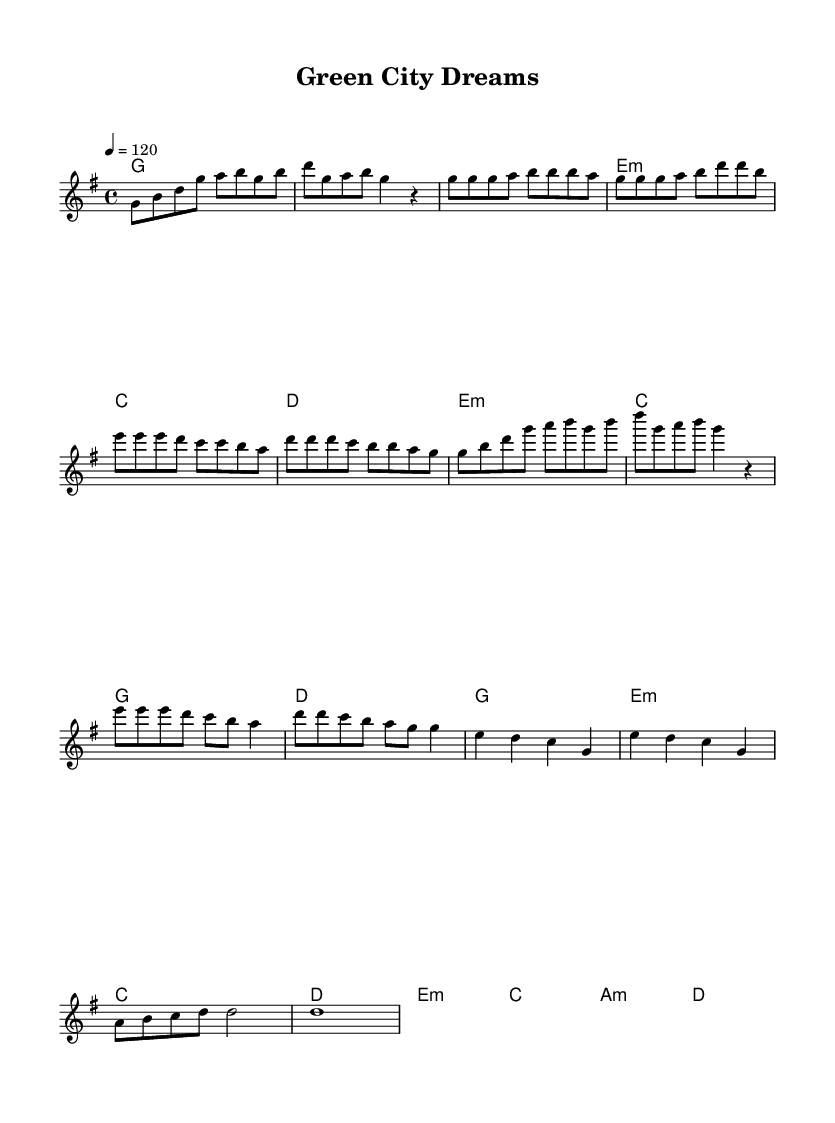What is the key signature of this music? The key signature is G major, which has one sharp (F#). This can be found at the beginning of the score, indicated by the sharp symbol placed on the staff.
Answer: G major What is the time signature of this composition? The time signature is four-four, which is indicated by the "4/4" at the beginning of the score. This means there are four beats in each measure, and the quarter note gets one beat.
Answer: Four-four What is the tempo marking of the piece? The tempo marking is 120 beats per minute, which is indicated by the instruction "4 = 120" in the tempo section. This indicates that the quarter note gets 120 beats in one minute.
Answer: 120 How many measures are in the verse section? The verse section contains four measures, as counted from the music notation provided for that section. Each section of music is divided by vertical lines and the verse explicitly starts after the intro.
Answer: Four What chord follows the D chord in the pre-chorus? The chord that follows the D chord in the pre-chorus is E minor. In the chord progression, after the D chord is the E minor chord, indicated in the harmonies section.
Answer: E minor What structure do K-Pop songs typically follow? K-Pop songs typically follow a verse-chorus structure, which can be observed in this composition with distinct sections labeled as Intro, Verse, Pre-Chorus, Chorus, and Bridge. This reflects the common organization of K-Pop music to engage listeners.
Answer: Verse-chorus Which section includes a slower tempo? The bridge section includes a slower tempo, as evidenced by the whole notes that are usually played at a more relaxed pace compared to the more rhythmic sections prior to it. This contrasts with the upbeat tempo earlier in the piece.
Answer: Bridge 